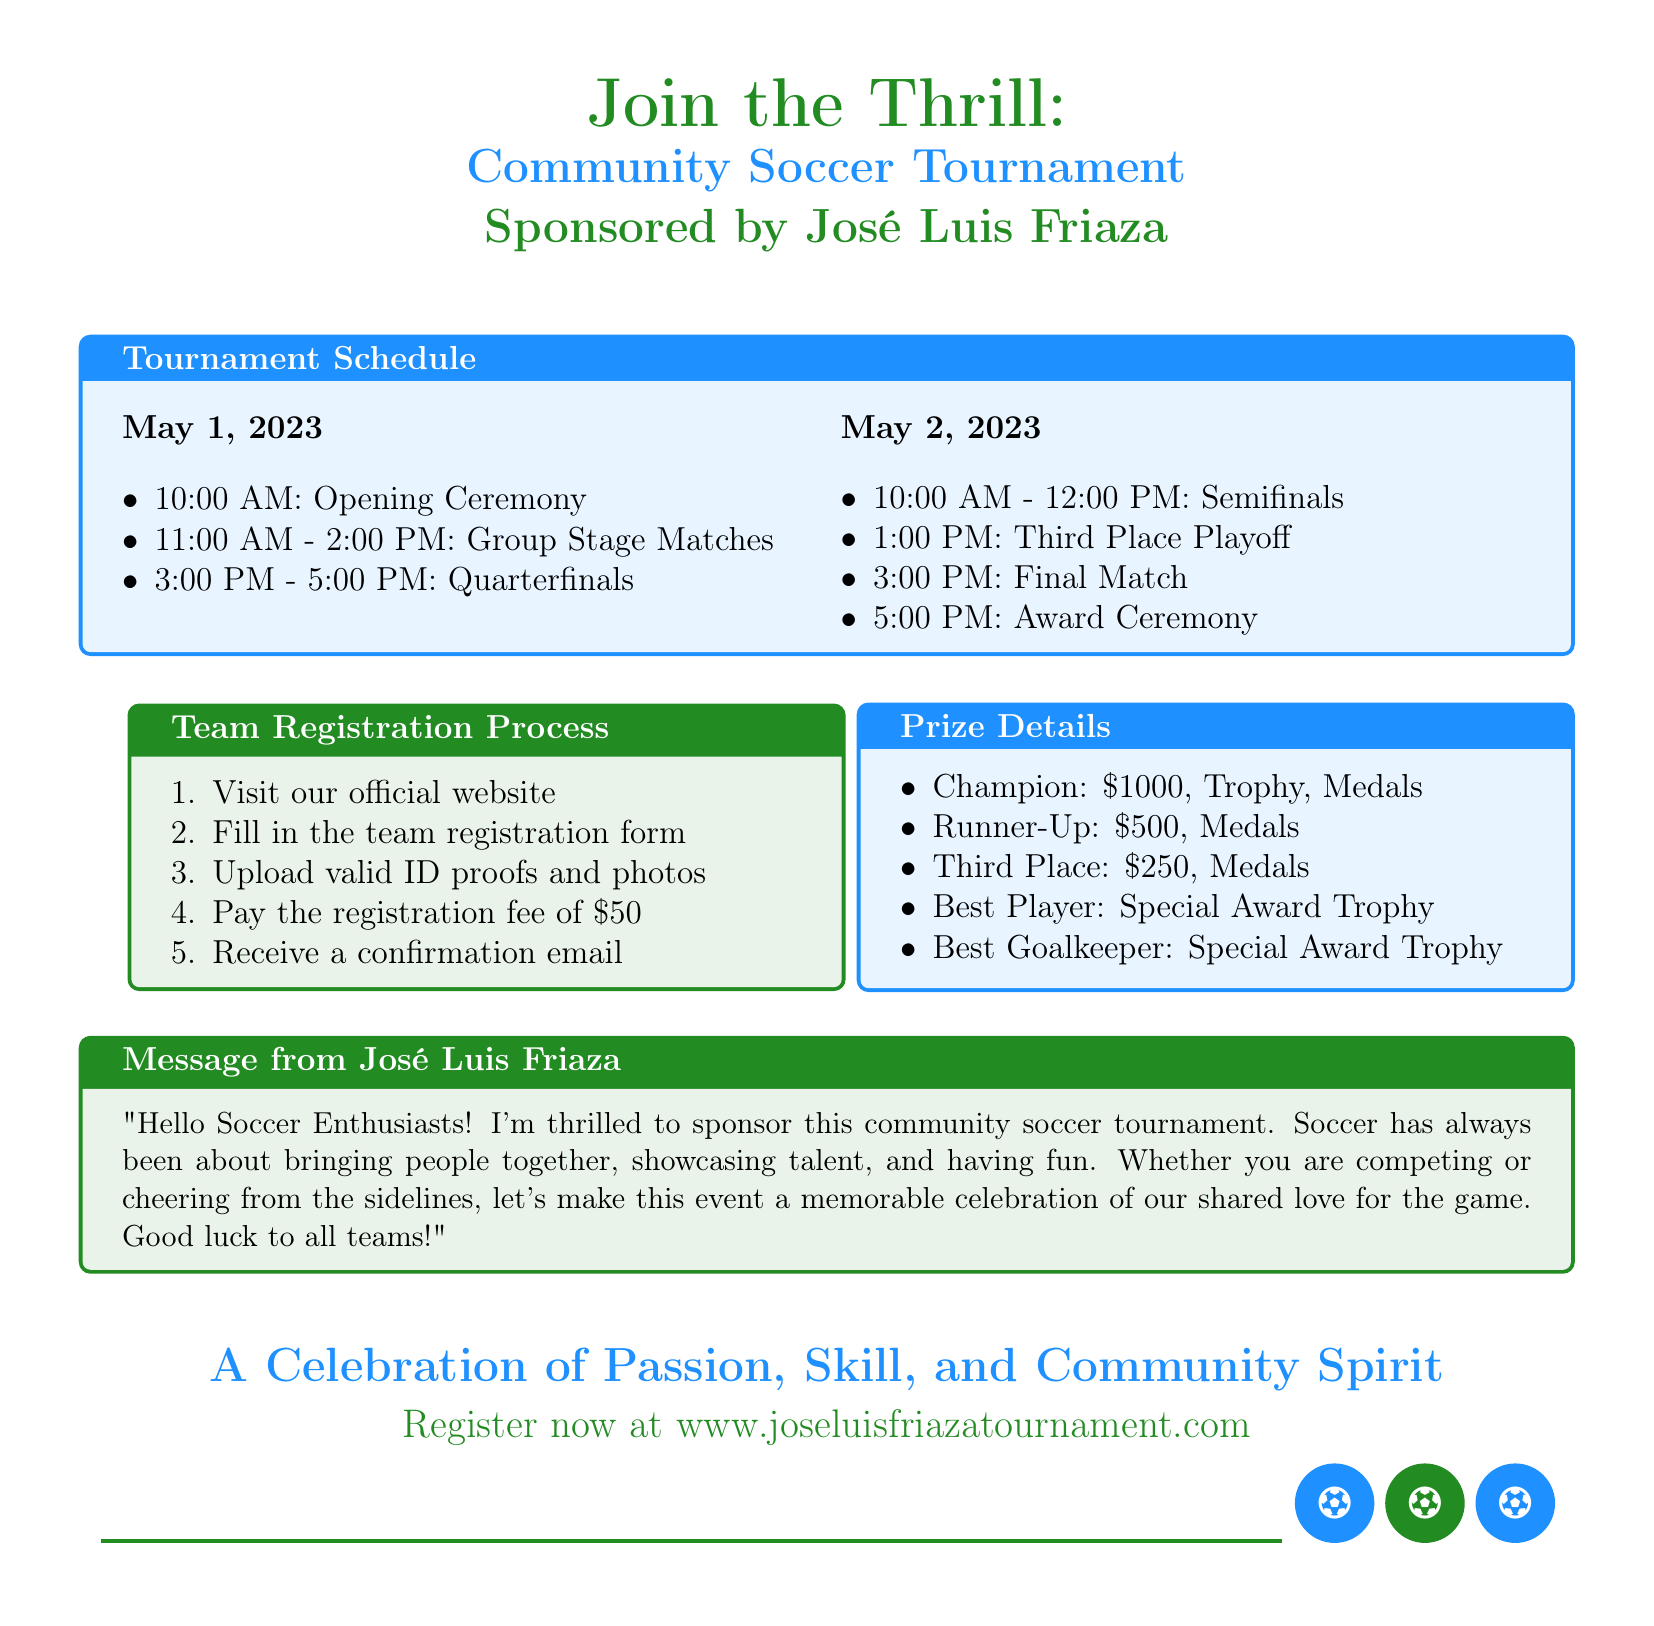What are the dates of the tournament? The document states the tournament dates are May 1 and May 2, 2023.
Answer: May 1 and May 2, 2023 What is the registration fee for a team? The document specifies a registration fee of $50 for teams.
Answer: $50 What time does the opening ceremony start? The document mentions that the opening ceremony starts at 10:00 AM on May 1, 2023.
Answer: 10:00 AM Who is sponsoring the tournament? The document indicates that José Luis Friaza is the tournament sponsor.
Answer: José Luis Friaza How many teams will receive medals as prizes? The document lists three prize categories that include medals (Champion, Runner-Up, Third Place).
Answer: Three teams What award is given to the Best Player? The document states that the Best Player will receive a Special Award Trophy.
Answer: Special Award Trophy What is the total prize amount for the Champion? The document specifies that the Champion will receive a total of $1000 along with a trophy and medals.
Answer: $1000 What special message does José Luis Friaza convey? The document includes a message about bringing people together and enjoying the game of soccer.
Answer: Bringing people together At what time is the Final Match scheduled? The document states that the Final Match is scheduled for 3:00 PM on May 2, 2023.
Answer: 3:00 PM 